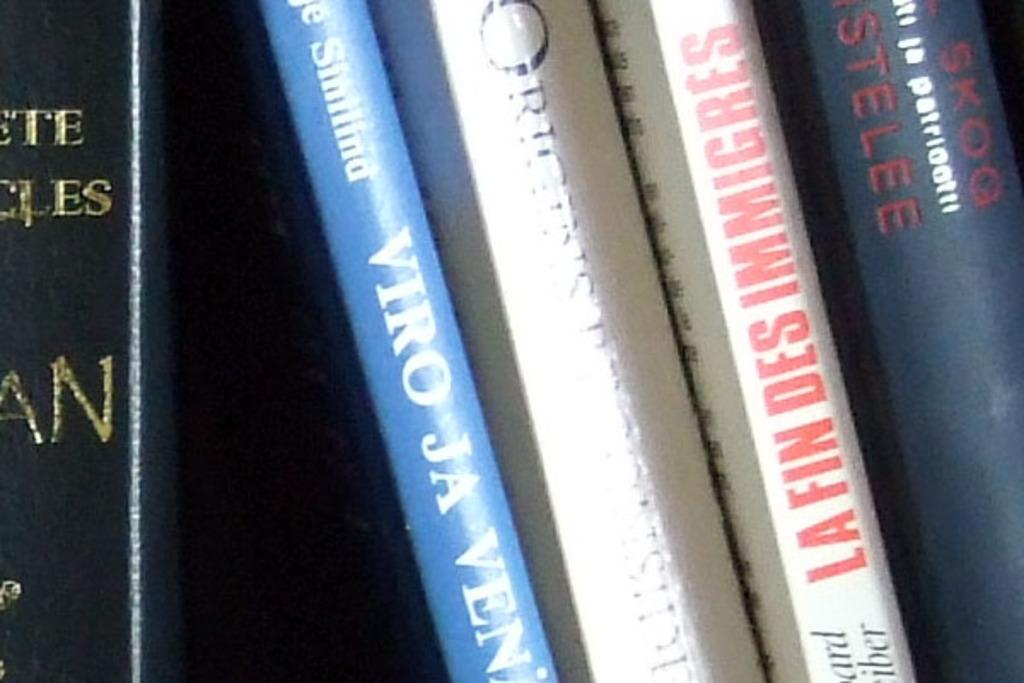Provide a one-sentence caption for the provided image. A collection of books includes the title LA FIN DES IMMIGRES. 